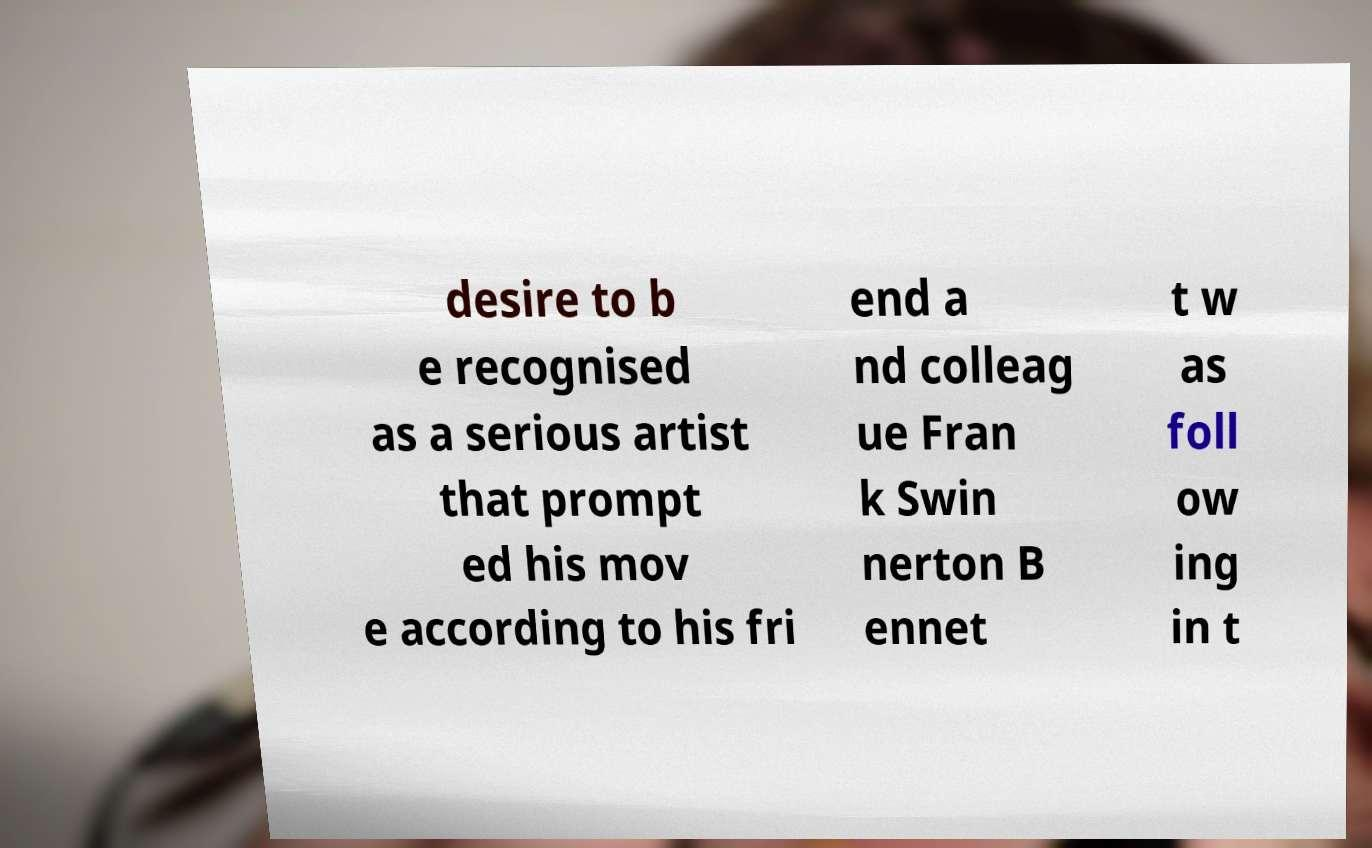Please identify and transcribe the text found in this image. desire to b e recognised as a serious artist that prompt ed his mov e according to his fri end a nd colleag ue Fran k Swin nerton B ennet t w as foll ow ing in t 